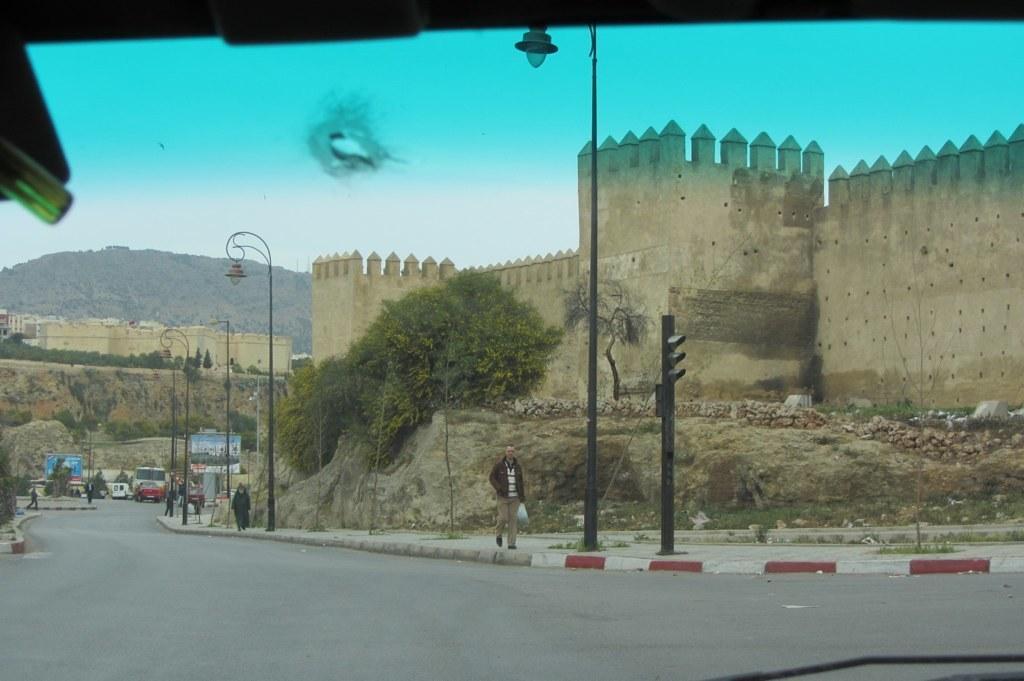How would you summarize this image in a sentence or two? In the center of the image, we can see a man walking and holding a bag. In the background, there are trees, buildings, traffic lights, poles and some other vehicles on the road. 